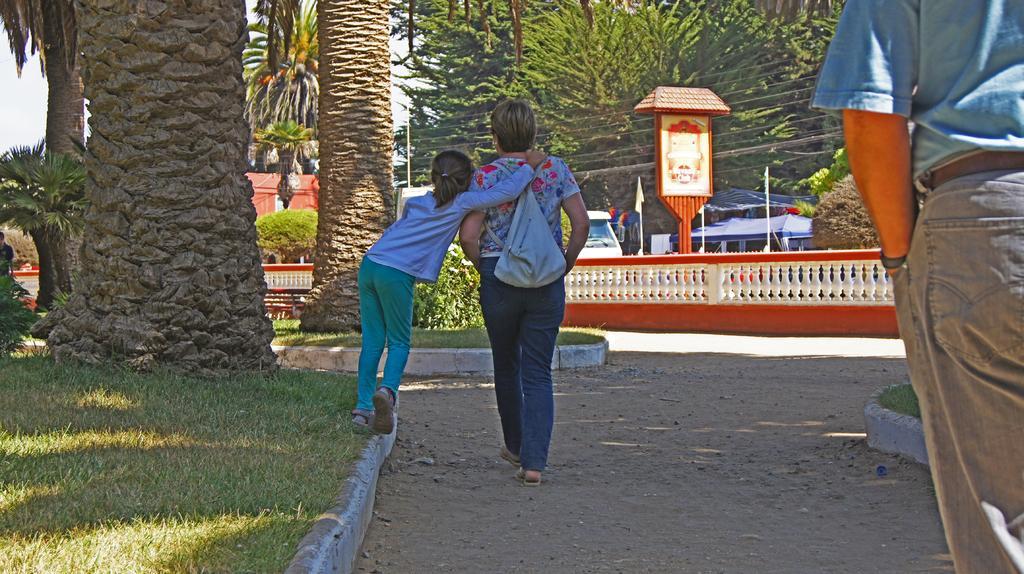How would you summarize this image in a sentence or two? In this image there are two people walking on the path, one is walking on the side wall of a grass and the other one is wearing a bag. On the right side of the image there is another person. In the background of the image there are trees, plants, fencing wall, a few vehicles parked, buildings, flags, grass and the sky. 